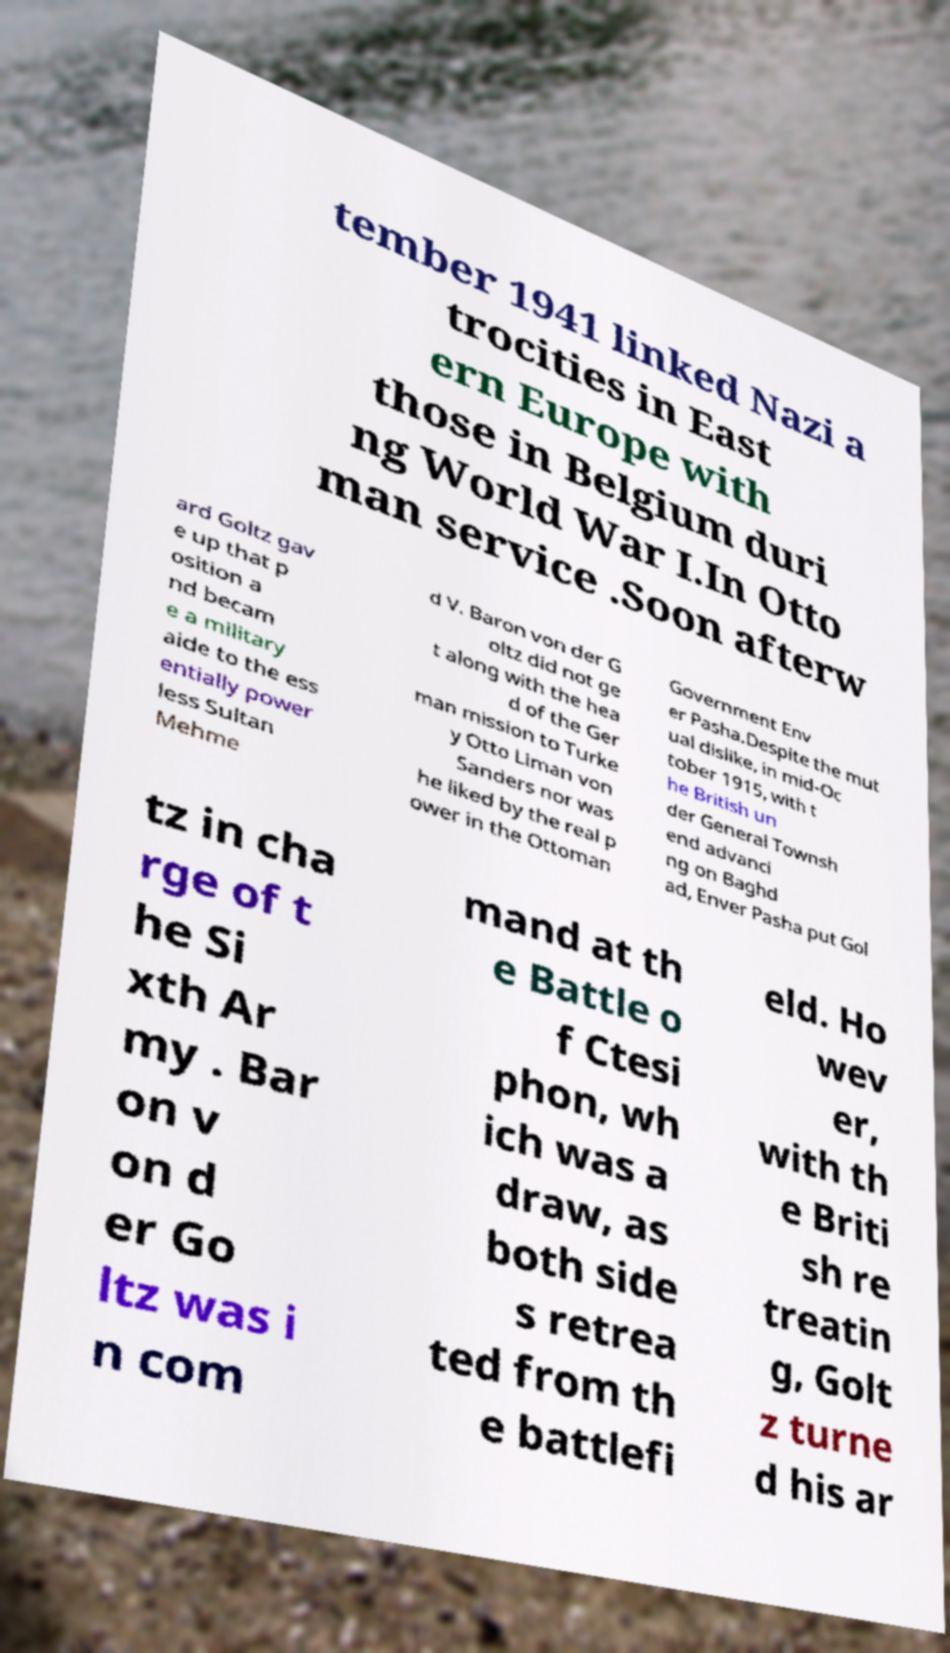For documentation purposes, I need the text within this image transcribed. Could you provide that? tember 1941 linked Nazi a trocities in East ern Europe with those in Belgium duri ng World War I.In Otto man service .Soon afterw ard Goltz gav e up that p osition a nd becam e a military aide to the ess entially power less Sultan Mehme d V. Baron von der G oltz did not ge t along with the hea d of the Ger man mission to Turke y Otto Liman von Sanders nor was he liked by the real p ower in the Ottoman Government Env er Pasha.Despite the mut ual dislike, in mid-Oc tober 1915, with t he British un der General Townsh end advanci ng on Baghd ad, Enver Pasha put Gol tz in cha rge of t he Si xth Ar my . Bar on v on d er Go ltz was i n com mand at th e Battle o f Ctesi phon, wh ich was a draw, as both side s retrea ted from th e battlefi eld. Ho wev er, with th e Briti sh re treatin g, Golt z turne d his ar 